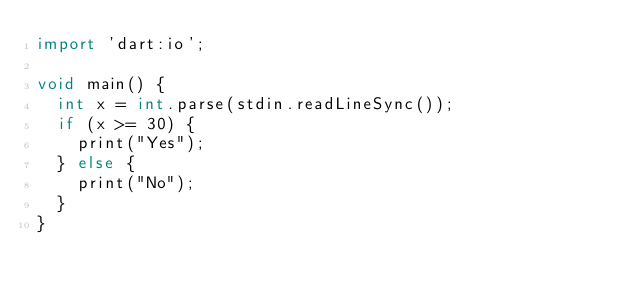<code> <loc_0><loc_0><loc_500><loc_500><_Dart_>import 'dart:io';

void main() {
  int x = int.parse(stdin.readLineSync());
  if (x >= 30) {
    print("Yes");
  } else {
    print("No");
  }
}</code> 